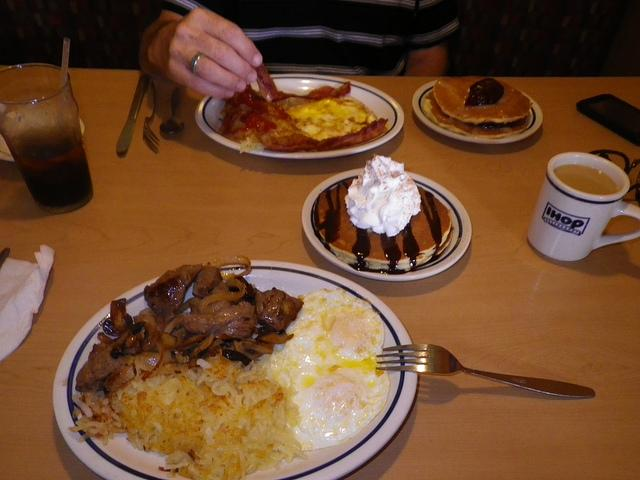What food on the table contains the highest amount of fat? Please explain your reasoning. bacon. Meat has more fat than the other food items. 